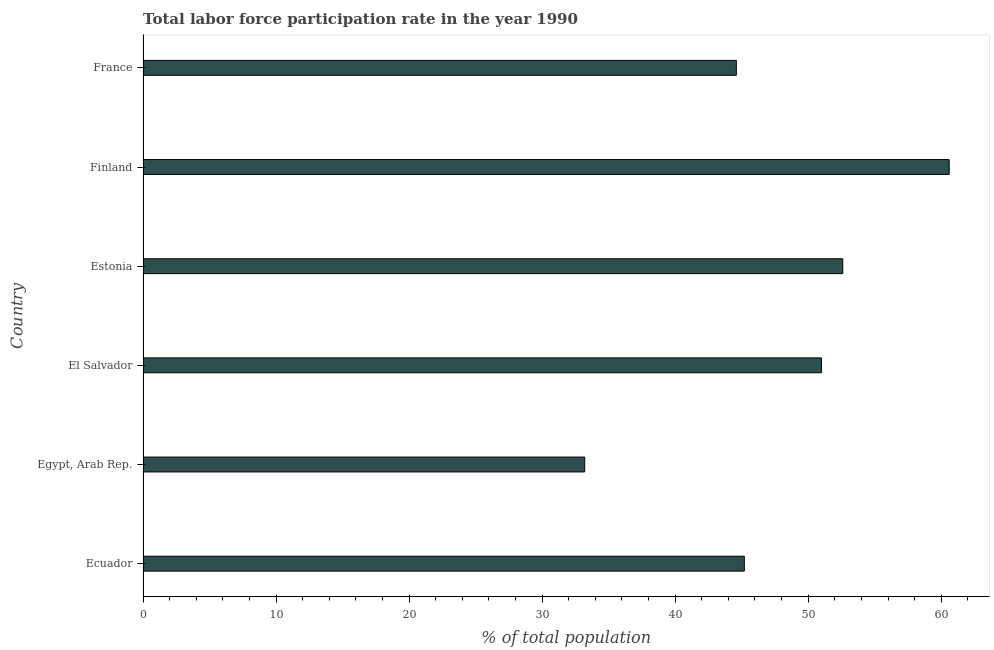Does the graph contain any zero values?
Give a very brief answer. No. What is the title of the graph?
Offer a very short reply. Total labor force participation rate in the year 1990. What is the label or title of the X-axis?
Offer a very short reply. % of total population. What is the total labor force participation rate in Finland?
Provide a short and direct response. 60.6. Across all countries, what is the maximum total labor force participation rate?
Offer a terse response. 60.6. Across all countries, what is the minimum total labor force participation rate?
Make the answer very short. 33.2. In which country was the total labor force participation rate maximum?
Ensure brevity in your answer.  Finland. In which country was the total labor force participation rate minimum?
Your response must be concise. Egypt, Arab Rep. What is the sum of the total labor force participation rate?
Your response must be concise. 287.2. What is the average total labor force participation rate per country?
Ensure brevity in your answer.  47.87. What is the median total labor force participation rate?
Ensure brevity in your answer.  48.1. What is the ratio of the total labor force participation rate in El Salvador to that in France?
Provide a short and direct response. 1.14. Is the difference between the total labor force participation rate in El Salvador and France greater than the difference between any two countries?
Give a very brief answer. No. What is the difference between the highest and the second highest total labor force participation rate?
Give a very brief answer. 8. What is the difference between the highest and the lowest total labor force participation rate?
Offer a very short reply. 27.4. In how many countries, is the total labor force participation rate greater than the average total labor force participation rate taken over all countries?
Ensure brevity in your answer.  3. How many countries are there in the graph?
Ensure brevity in your answer.  6. Are the values on the major ticks of X-axis written in scientific E-notation?
Offer a terse response. No. What is the % of total population in Ecuador?
Provide a short and direct response. 45.2. What is the % of total population of Egypt, Arab Rep.?
Your answer should be very brief. 33.2. What is the % of total population of Estonia?
Your answer should be very brief. 52.6. What is the % of total population of Finland?
Make the answer very short. 60.6. What is the % of total population in France?
Provide a succinct answer. 44.6. What is the difference between the % of total population in Ecuador and Estonia?
Give a very brief answer. -7.4. What is the difference between the % of total population in Ecuador and Finland?
Your response must be concise. -15.4. What is the difference between the % of total population in Egypt, Arab Rep. and El Salvador?
Offer a terse response. -17.8. What is the difference between the % of total population in Egypt, Arab Rep. and Estonia?
Your answer should be compact. -19.4. What is the difference between the % of total population in Egypt, Arab Rep. and Finland?
Offer a terse response. -27.4. What is the difference between the % of total population in Egypt, Arab Rep. and France?
Ensure brevity in your answer.  -11.4. What is the difference between the % of total population in Estonia and France?
Make the answer very short. 8. What is the ratio of the % of total population in Ecuador to that in Egypt, Arab Rep.?
Make the answer very short. 1.36. What is the ratio of the % of total population in Ecuador to that in El Salvador?
Provide a short and direct response. 0.89. What is the ratio of the % of total population in Ecuador to that in Estonia?
Give a very brief answer. 0.86. What is the ratio of the % of total population in Ecuador to that in Finland?
Give a very brief answer. 0.75. What is the ratio of the % of total population in Egypt, Arab Rep. to that in El Salvador?
Your response must be concise. 0.65. What is the ratio of the % of total population in Egypt, Arab Rep. to that in Estonia?
Keep it short and to the point. 0.63. What is the ratio of the % of total population in Egypt, Arab Rep. to that in Finland?
Offer a very short reply. 0.55. What is the ratio of the % of total population in Egypt, Arab Rep. to that in France?
Offer a terse response. 0.74. What is the ratio of the % of total population in El Salvador to that in Finland?
Your answer should be compact. 0.84. What is the ratio of the % of total population in El Salvador to that in France?
Your answer should be compact. 1.14. What is the ratio of the % of total population in Estonia to that in Finland?
Your answer should be very brief. 0.87. What is the ratio of the % of total population in Estonia to that in France?
Offer a very short reply. 1.18. What is the ratio of the % of total population in Finland to that in France?
Offer a terse response. 1.36. 